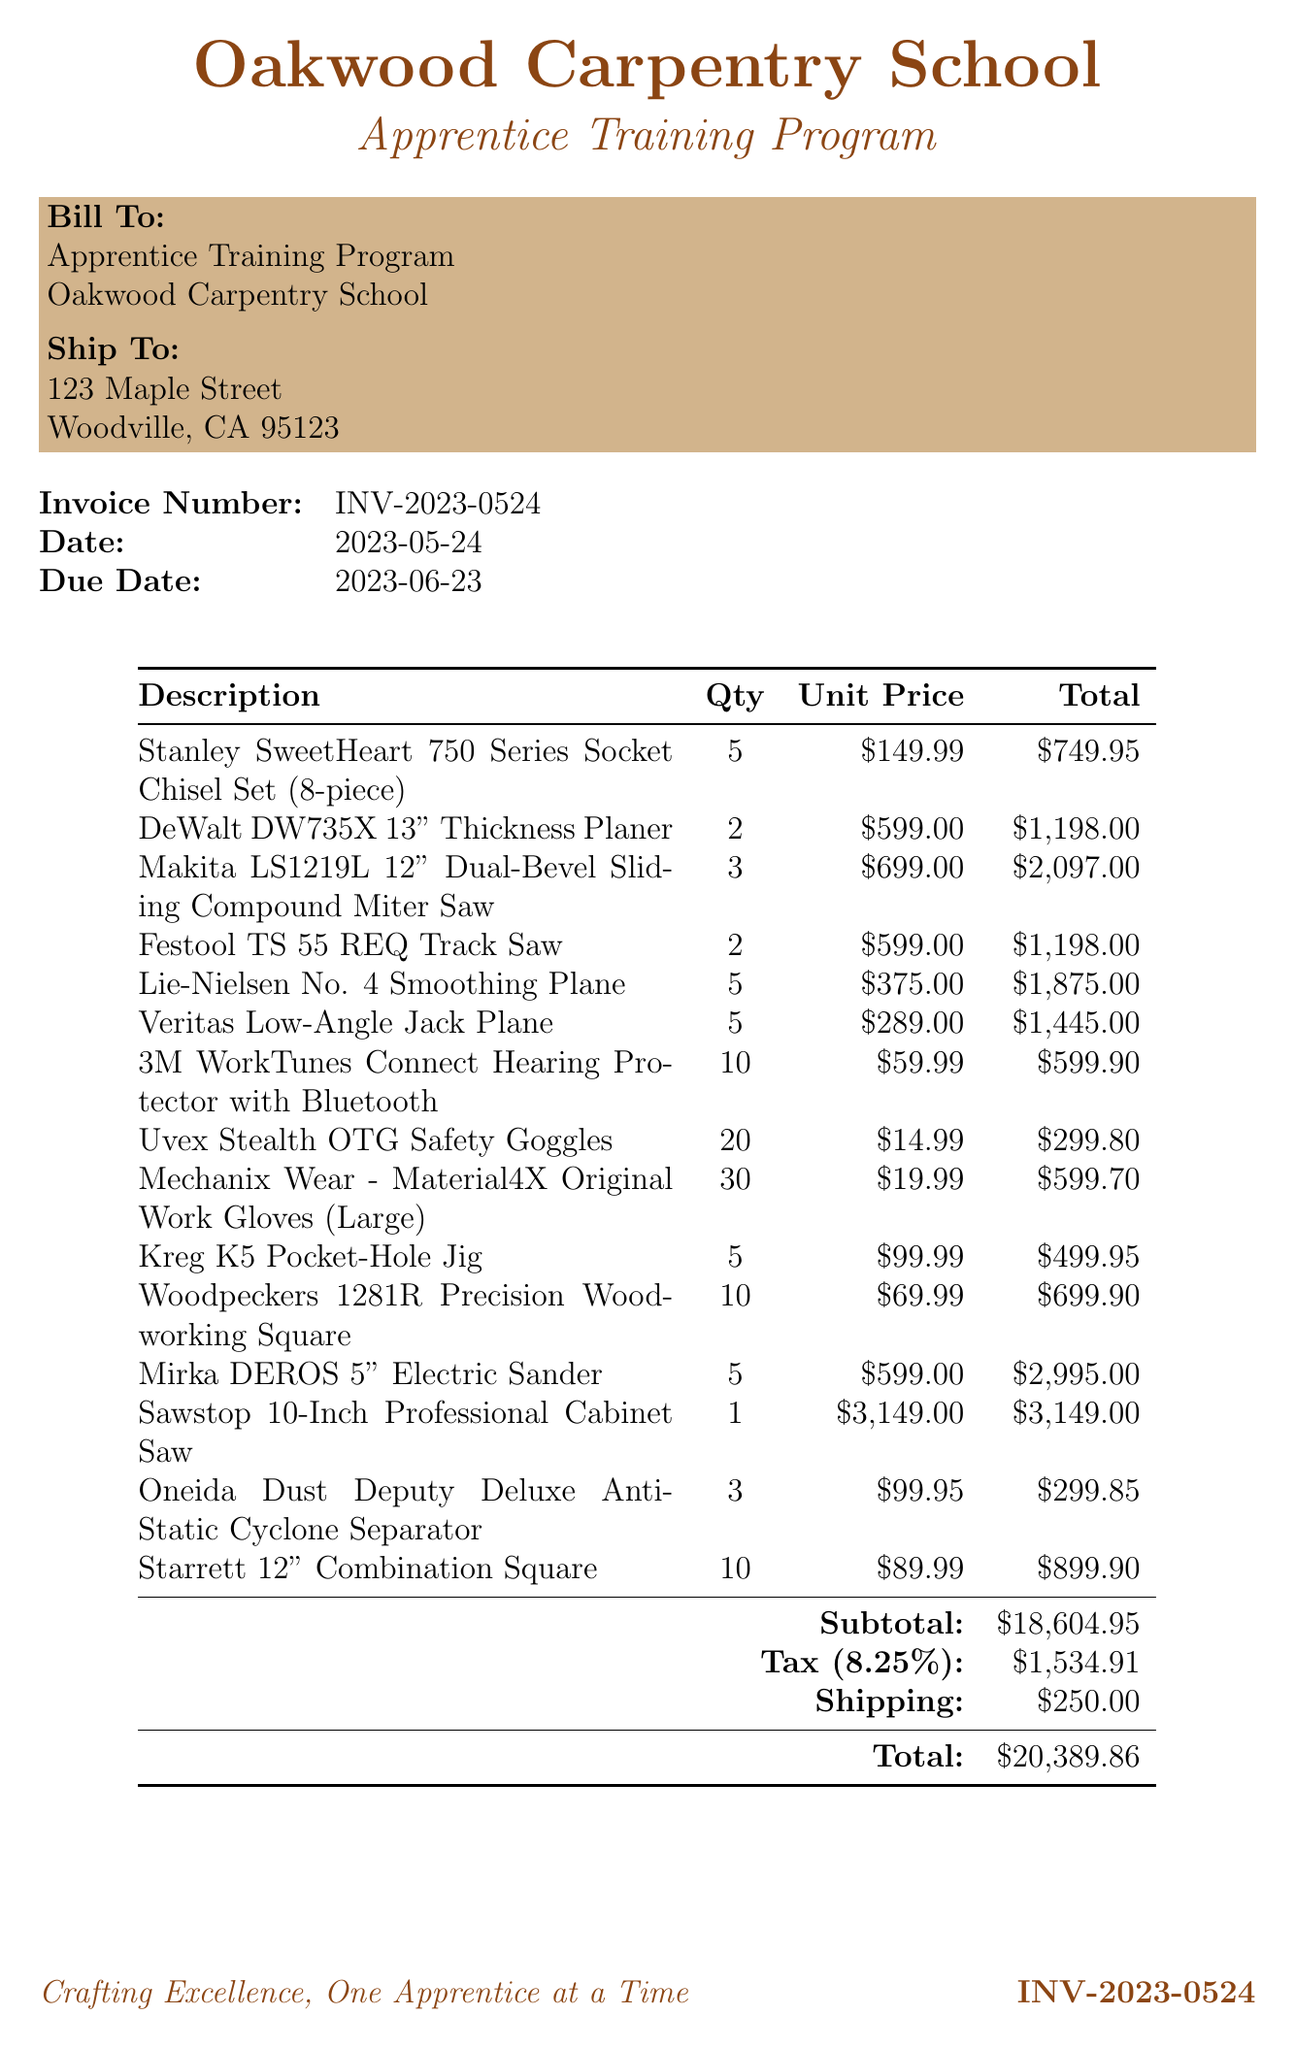What is the invoice number? The invoice number is a unique identifier for the document, which is INV-2023-0524.
Answer: INV-2023-0524 What is the subtotal of the items? The subtotal is the total amount before tax and shipping, which is $18604.95.
Answer: $18604.95 What is the tax rate applied? The tax rate is a percentage that is applied to the subtotal; in this case, it is 8.25%.
Answer: 8.25% How many safety goggles were purchased? The quantity of safety goggles is specified in the items list, which shows 20 Uvex Stealth OTG Safety Goggles.
Answer: 20 What is the total amount due? The total amount due at the bottom of the document includes the subtotal, tax, and shipping, totaling $20389.86.
Answer: $20389.86 What item is listed as the most expensive? The most expensive item is usually the one with the highest unit price, which is the Sawstop 10-Inch Professional Cabinet Saw at $3149.00.
Answer: Sawstop 10-Inch Professional Cabinet Saw What is the shipping cost? Shipping is an additional charge that they have included in the invoice, which is $250.00.
Answer: $250.00 Who is the bill to? The bill to section identifies the entity responsible for payment, which is the Apprentice Training Program, Oakwood Carpentry School.
Answer: Apprentice Training Program, Oakwood Carpentry School What item belongs to the category of personal protective equipment? Items specifically designed for safety and protection fall in this category, like the 3M WorkTunes Connect Hearing Protector.
Answer: 3M WorkTunes Connect Hearing Protector with Bluetooth 